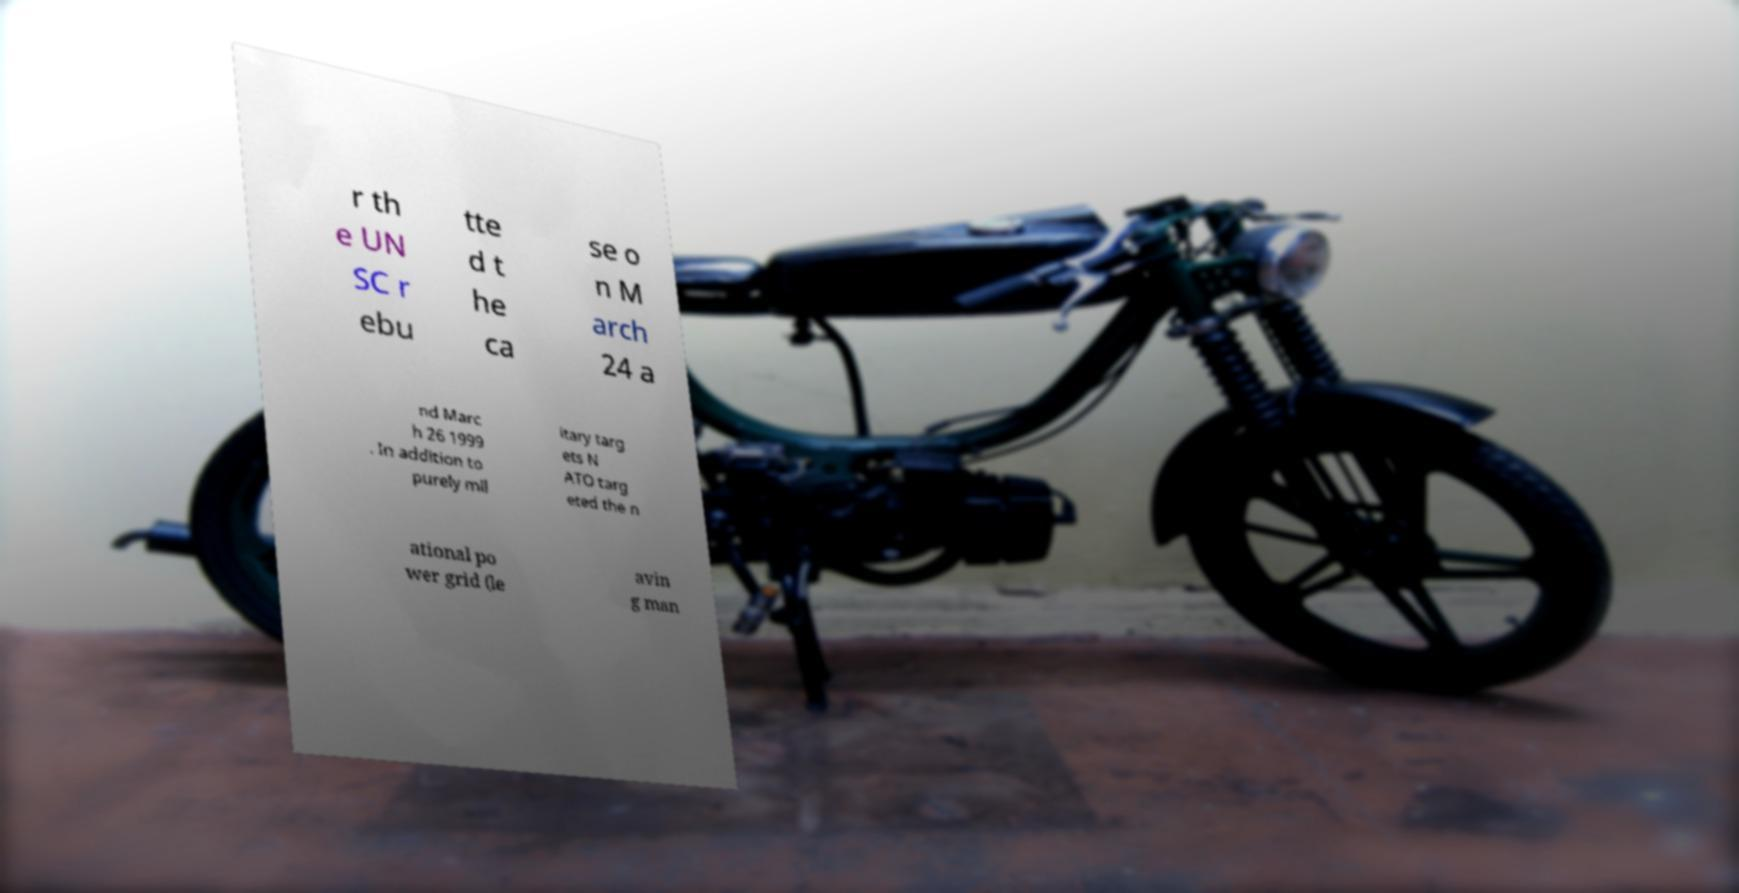What messages or text are displayed in this image? I need them in a readable, typed format. r th e UN SC r ebu tte d t he ca se o n M arch 24 a nd Marc h 26 1999 . In addition to purely mil itary targ ets N ATO targ eted the n ational po wer grid (le avin g man 